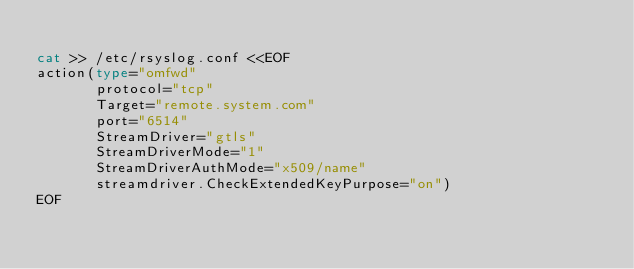<code> <loc_0><loc_0><loc_500><loc_500><_Bash_>
cat >> /etc/rsyslog.conf <<EOF
action(type="omfwd"
       protocol="tcp"
       Target="remote.system.com"
       port="6514"
       StreamDriver="gtls"
       StreamDriverMode="1"
       StreamDriverAuthMode="x509/name"
       streamdriver.CheckExtendedKeyPurpose="on")
EOF
</code> 